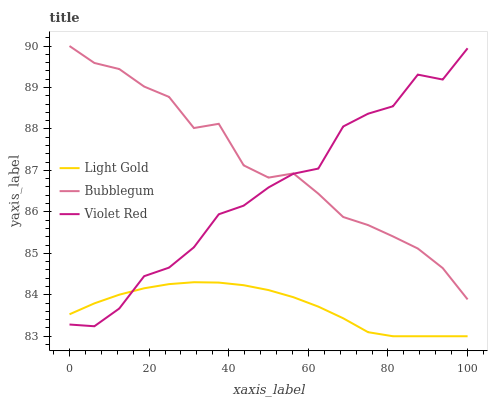Does Light Gold have the minimum area under the curve?
Answer yes or no. Yes. Does Bubblegum have the maximum area under the curve?
Answer yes or no. Yes. Does Bubblegum have the minimum area under the curve?
Answer yes or no. No. Does Light Gold have the maximum area under the curve?
Answer yes or no. No. Is Light Gold the smoothest?
Answer yes or no. Yes. Is Violet Red the roughest?
Answer yes or no. Yes. Is Bubblegum the smoothest?
Answer yes or no. No. Is Bubblegum the roughest?
Answer yes or no. No. Does Light Gold have the lowest value?
Answer yes or no. Yes. Does Bubblegum have the lowest value?
Answer yes or no. No. Does Bubblegum have the highest value?
Answer yes or no. Yes. Does Light Gold have the highest value?
Answer yes or no. No. Is Light Gold less than Bubblegum?
Answer yes or no. Yes. Is Bubblegum greater than Light Gold?
Answer yes or no. Yes. Does Light Gold intersect Violet Red?
Answer yes or no. Yes. Is Light Gold less than Violet Red?
Answer yes or no. No. Is Light Gold greater than Violet Red?
Answer yes or no. No. Does Light Gold intersect Bubblegum?
Answer yes or no. No. 